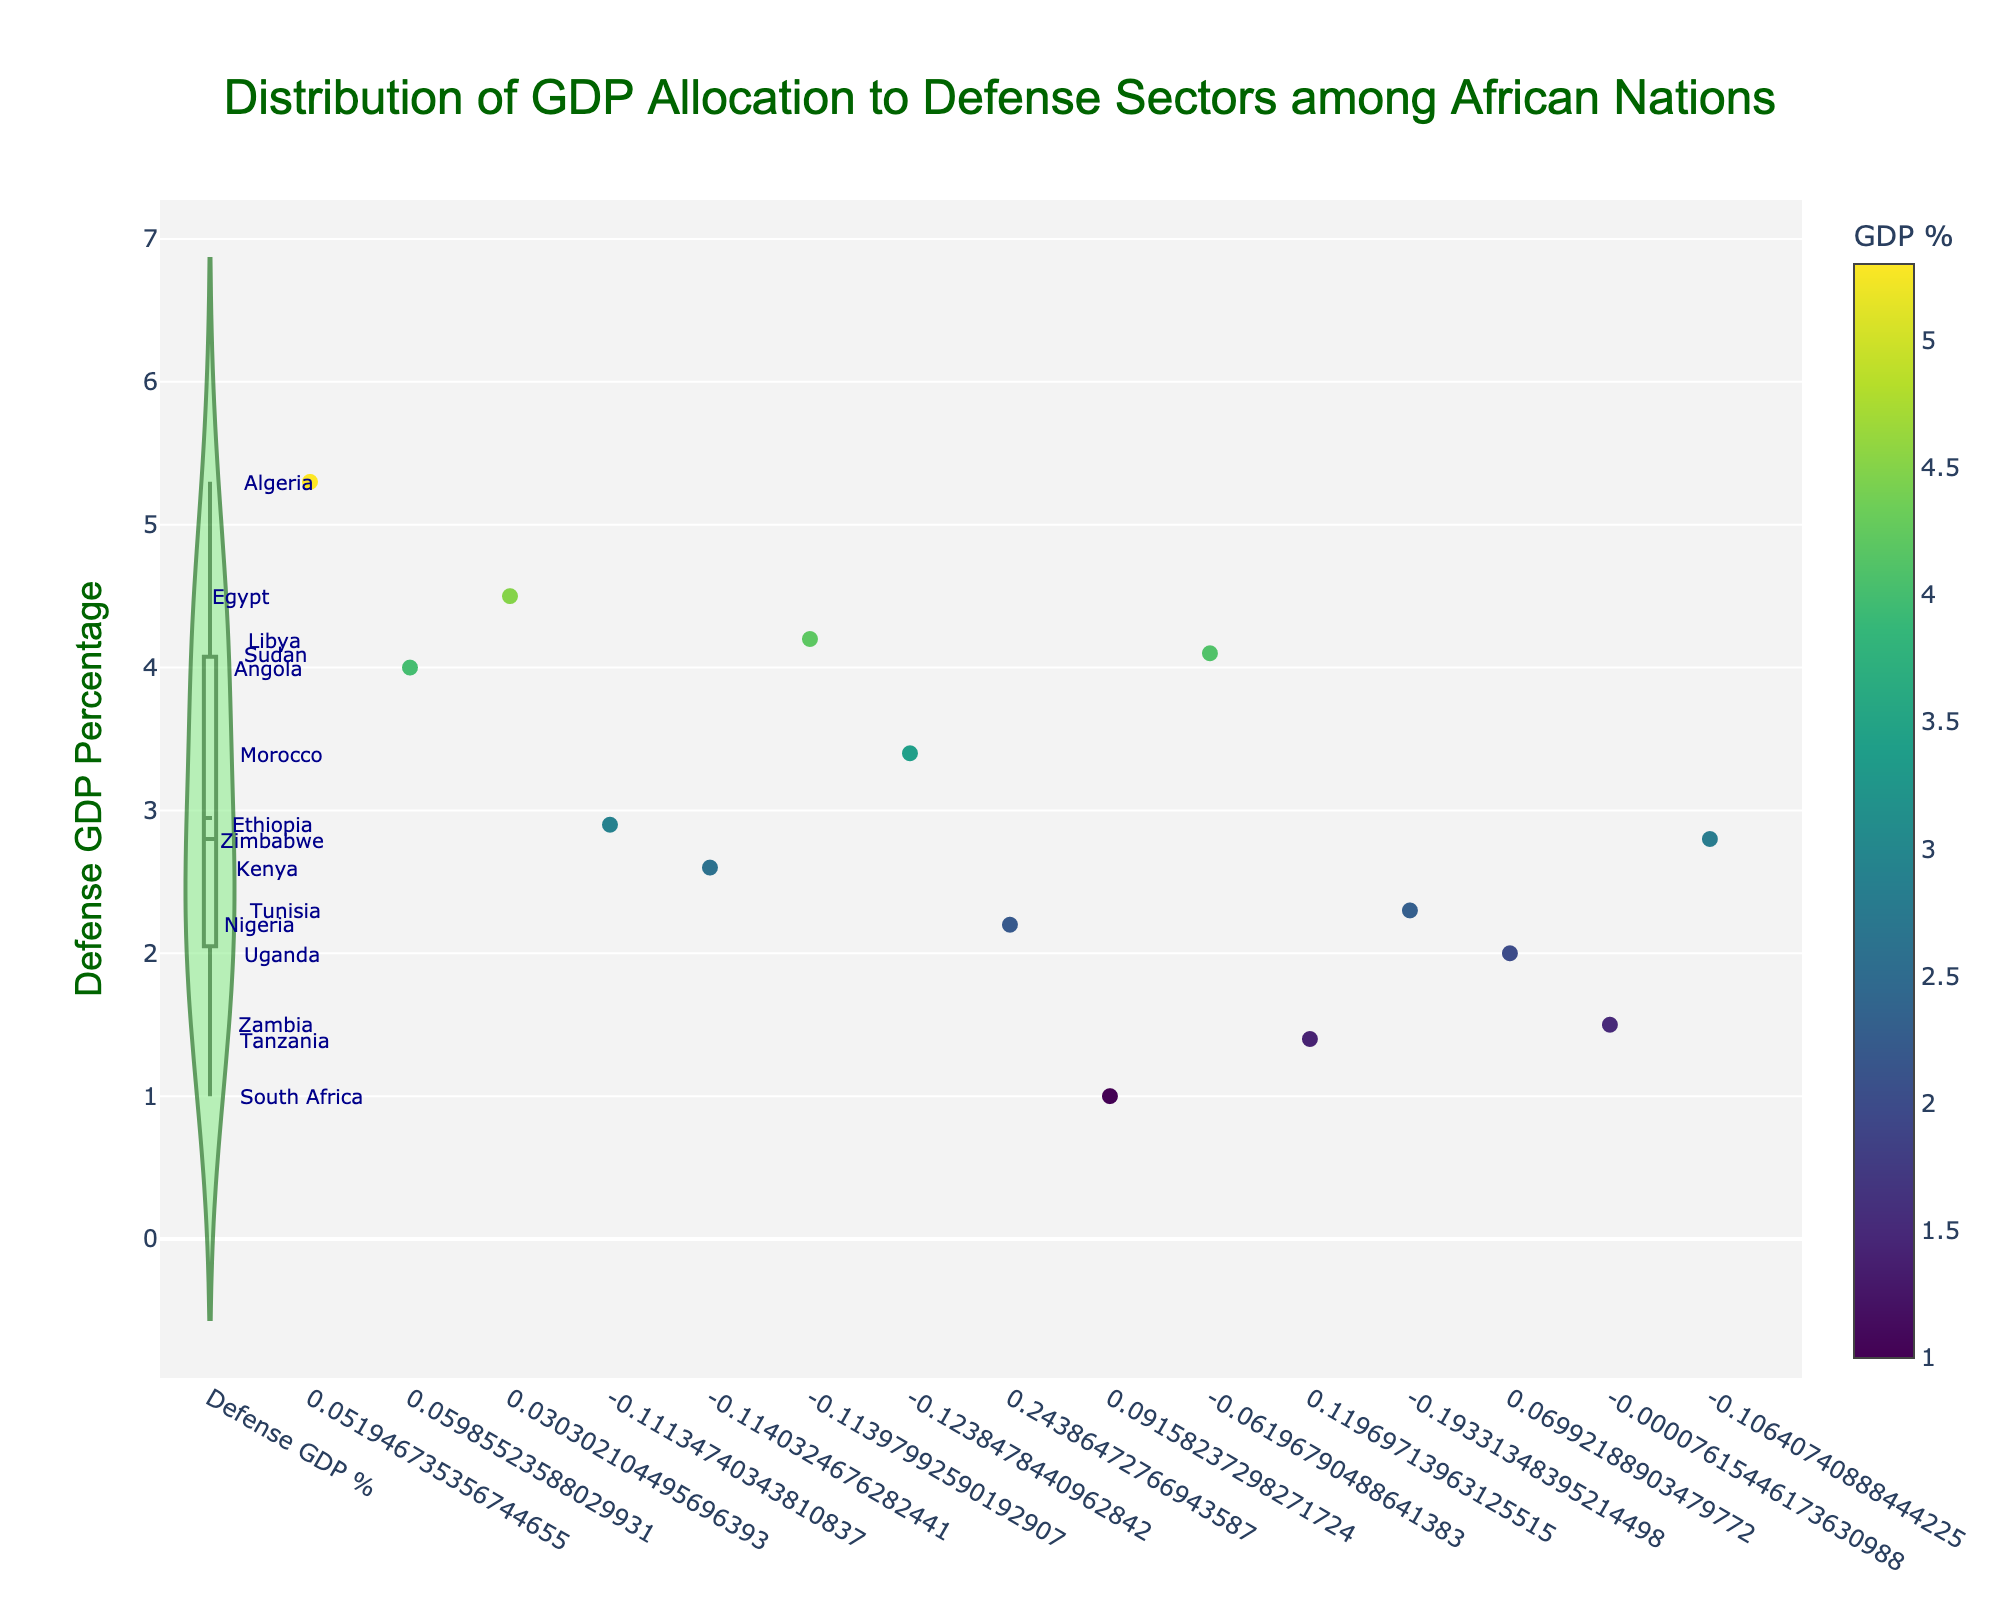What does the title of the plot indicate? The title of the plot is at the top of the figure and it provides a summary of what the plot is about.
Answer: Distribution of GDP Allocation to Defense Sectors among African Nations What is the range of the Defense GDP Percentage values shown in the plot? By examining the y-axis, we can see the minimum and maximum values of Defense GDP Percentage among the countries.
Answer: 1.0% to 5.3% Which country allocates the highest percentage of its GDP to defense? By looking at the data points or annotations in the plot, we can identify the country with the highest value on the y-axis.
Answer: Algeria What color is used for the scatter plot points in the figure? The scatter plot points are colored based on the 'Viridis' colorscale as indicated in the figure.
Answer: Viridis How many countries allocate more than 4% of their GDP to defense? By counting the specific data points above the 4% mark on the y-axis, we can find the answer.
Answer: 5 countries What is the average GDP percentage allocated to defense among the countries shown? Sum up all the values and divide by the number of countries. (5.3 + 4.0 + 4.5 + 2.9 + 2.6 + 4.2 + 3.4 + 2.2 + 1.0 + 4.1 + 1.4 + 2.3 + 2.0 + 1.5 + 2.8) / 15 = 3.0
Answer: 3.0% Which country has the lowest allocation percentage for defense, and what is that percentage? By identifying the country at the lowest value on the y-axis and reading the associated percentage, we get the answer.
Answer: South Africa, 1.0% Compare the GDP percentage allocated to defense by Egypt and Nigeria. Which is higher? By locating both Egypt and Nigeria on the y-axis and comparing their values, we determine which is higher.
Answer: Egypt (4.5%) is higher than Nigeria (2.2%) What is the median value of the Defense GDP Percentage among these countries? Arrange the percentages in ascending order and find the middle value or average the two middle values. The ordered values are [1.0, 1.4, 1.5, 2.0, 2.2, 2.3, 2.6, 2.8, 2.9, 3.4, 4.0, 4.1, 4.2, 4.5, 5.3]. The median here is 2.8 (the 8th value).
Answer: 2.8 Which country has the closest Defense GDP Percentage to the average value, and what is the percentage? Calculate the absolute difference between each country's value and the average (3.0%), then find the smallest difference.
Answer: Somalia, 2.9% 